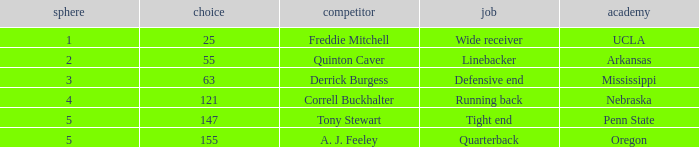Who was the player who was pick number 147? Tony Stewart. 